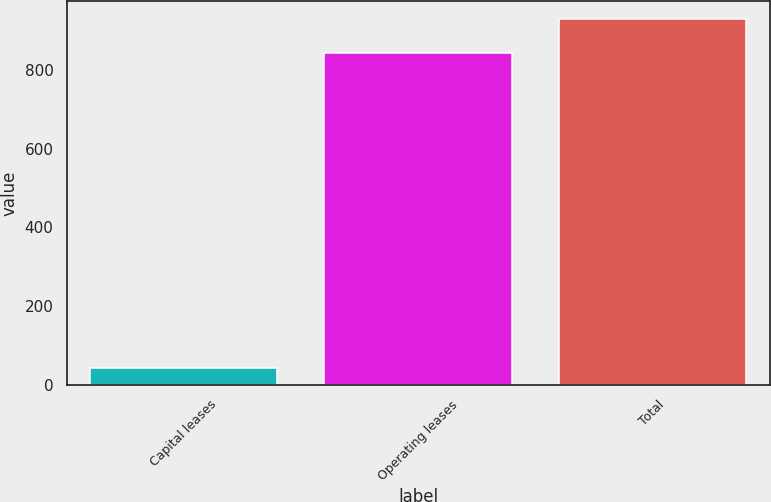<chart> <loc_0><loc_0><loc_500><loc_500><bar_chart><fcel>Capital leases<fcel>Operating leases<fcel>Total<nl><fcel>43.5<fcel>843.7<fcel>928.07<nl></chart> 